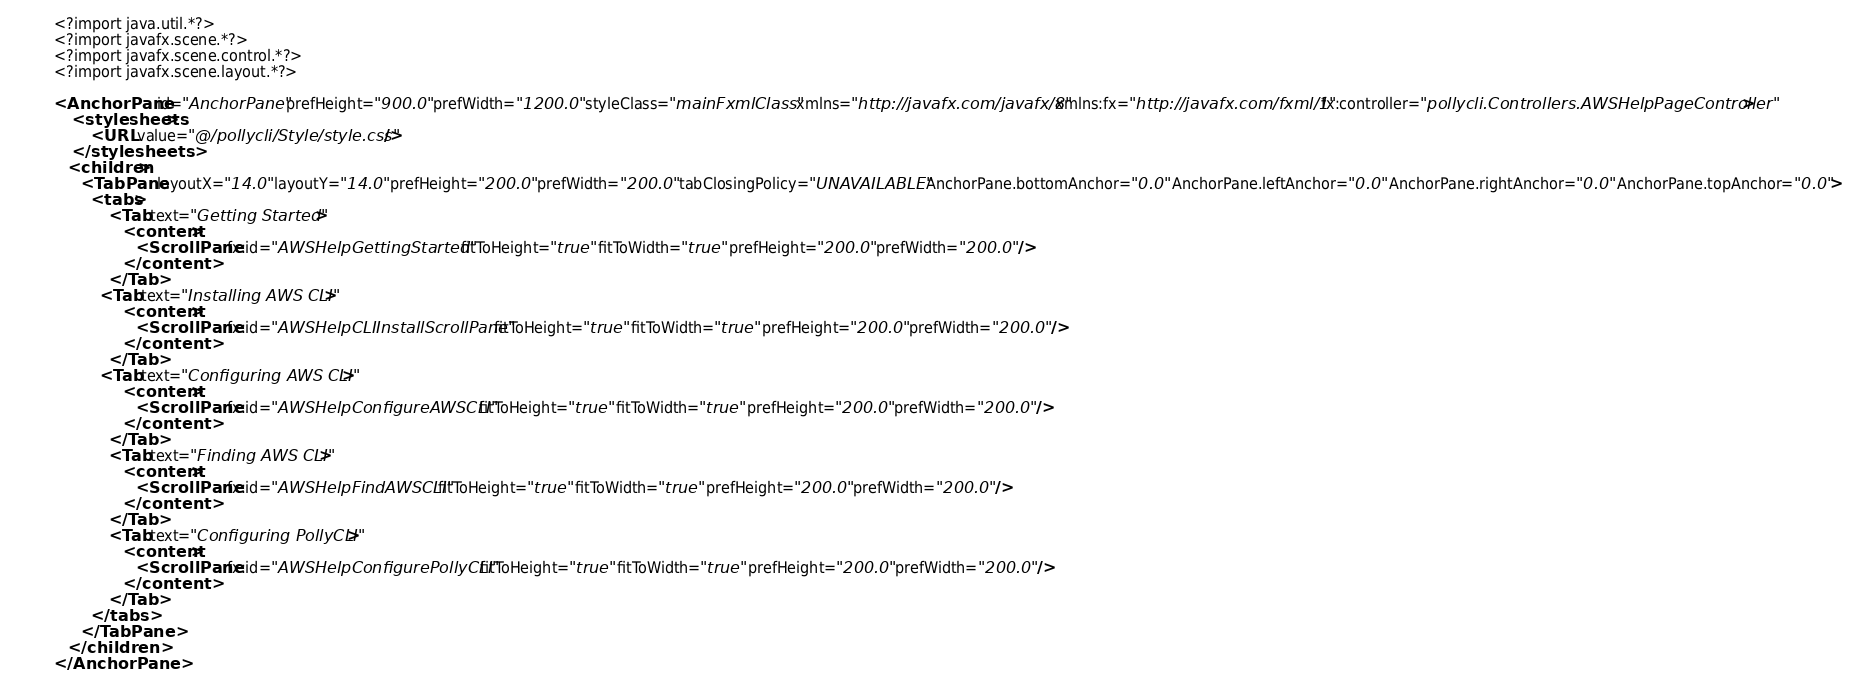Convert code to text. <code><loc_0><loc_0><loc_500><loc_500><_XML_><?import java.util.*?>
<?import javafx.scene.*?>
<?import javafx.scene.control.*?>
<?import javafx.scene.layout.*?>

<AnchorPane id="AnchorPane" prefHeight="900.0" prefWidth="1200.0" styleClass="mainFxmlClass" xmlns="http://javafx.com/javafx/8" xmlns:fx="http://javafx.com/fxml/1" fx:controller="pollycli.Controllers.AWSHelpPageController">
    <stylesheets>
        <URL value="@/pollycli/Style/style.css" />
    </stylesheets>
   <children>
      <TabPane layoutX="14.0" layoutY="14.0" prefHeight="200.0" prefWidth="200.0" tabClosingPolicy="UNAVAILABLE" AnchorPane.bottomAnchor="0.0" AnchorPane.leftAnchor="0.0" AnchorPane.rightAnchor="0.0" AnchorPane.topAnchor="0.0">
        <tabs>
            <Tab text="Getting Started">
               <content>
                  <ScrollPane fx:id="AWSHelpGettingStarted" fitToHeight="true" fitToWidth="true" prefHeight="200.0" prefWidth="200.0" />
               </content>
            </Tab>
          <Tab text="Installing AWS CLI">
               <content>
                  <ScrollPane fx:id="AWSHelpCLIInstallScrollPane" fitToHeight="true" fitToWidth="true" prefHeight="200.0" prefWidth="200.0" />
               </content>
            </Tab>
          <Tab text="Configuring AWS CLI">
               <content>
                  <ScrollPane fx:id="AWSHelpConfigureAWSCLI" fitToHeight="true" fitToWidth="true" prefHeight="200.0" prefWidth="200.0" />
               </content>
            </Tab>
            <Tab text="Finding AWS CLI">
               <content>
                  <ScrollPane fx:id="AWSHelpFindAWSCLI" fitToHeight="true" fitToWidth="true" prefHeight="200.0" prefWidth="200.0" />
               </content>
            </Tab>
            <Tab text="Configuring PollyCLI">
               <content>
                  <ScrollPane fx:id="AWSHelpConfigurePollyCLI" fitToHeight="true" fitToWidth="true" prefHeight="200.0" prefWidth="200.0" />
               </content>
            </Tab>
        </tabs>
      </TabPane>
   </children>
</AnchorPane>
</code> 